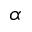Convert formula to latex. <formula><loc_0><loc_0><loc_500><loc_500>\alpha</formula> 